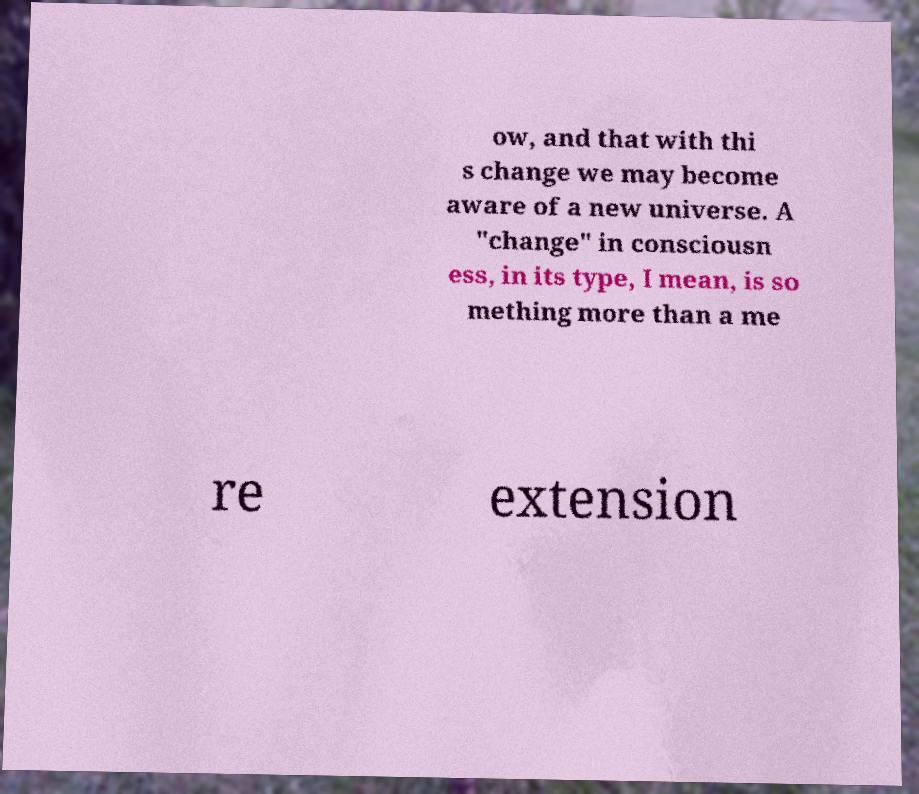Could you assist in decoding the text presented in this image and type it out clearly? ow, and that with thi s change we may become aware of a new universe. A "change" in consciousn ess, in its type, I mean, is so mething more than a me re extension 